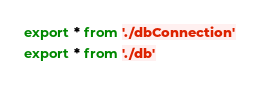<code> <loc_0><loc_0><loc_500><loc_500><_TypeScript_>export * from './dbConnection'
export * from './db'
</code> 